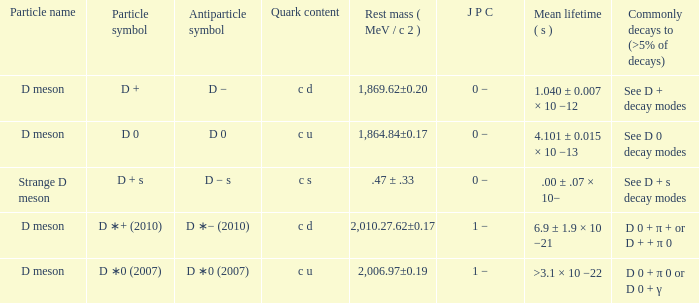Give me the full table as a dictionary. {'header': ['Particle name', 'Particle symbol', 'Antiparticle symbol', 'Quark content', 'Rest mass ( MeV / c 2 )', 'J P C', 'Mean lifetime ( s )', 'Commonly decays to (>5% of decays)'], 'rows': [['D meson', 'D +', 'D −', 'c d', '1,869.62±0.20', '0 −', '1.040 ± 0.007 × 10 −12', 'See D + decay modes'], ['D meson', 'D 0', 'D 0', 'c u', '1,864.84±0.17', '0 −', '4.101 ± 0.015 × 10 −13', 'See D 0 decay modes'], ['Strange D meson', 'D + s', 'D − s', 'c s', '.47 ± .33', '0 −', '.00 ± .07 × 10−', 'See D + s decay modes'], ['D meson', 'D ∗+ (2010)', 'D ∗− (2010)', 'c d', '2,010.27.62±0.17', '1 −', '6.9 ± 1.9 × 10 −21', 'D 0 + π + or D + + π 0'], ['D meson', 'D ∗0 (2007)', 'D ∗0 (2007)', 'c u', '2,006.97±0.19', '1 −', '>3.1 × 10 −22', 'D 0 + π 0 or D 0 + γ']]} What is the j p c that commonly decays (>5% of decays) d 0 + π 0 or d 0 + γ? 1 −. 